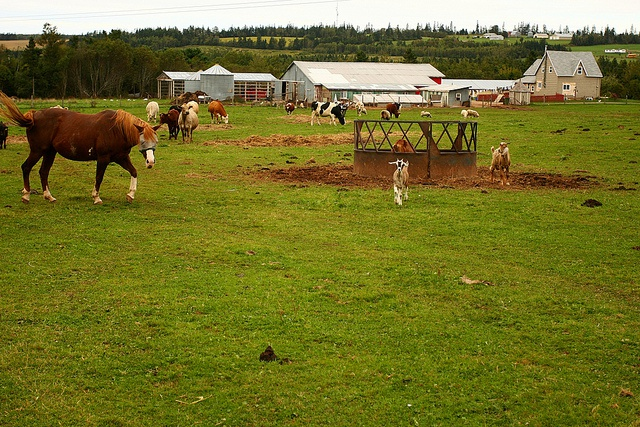Describe the objects in this image and their specific colors. I can see horse in white, black, maroon, and olive tones, sheep in white, brown, maroon, olive, and black tones, sheep in white, tan, olive, and maroon tones, cow in white, black, khaki, and tan tones, and cow in white, black, olive, and maroon tones in this image. 